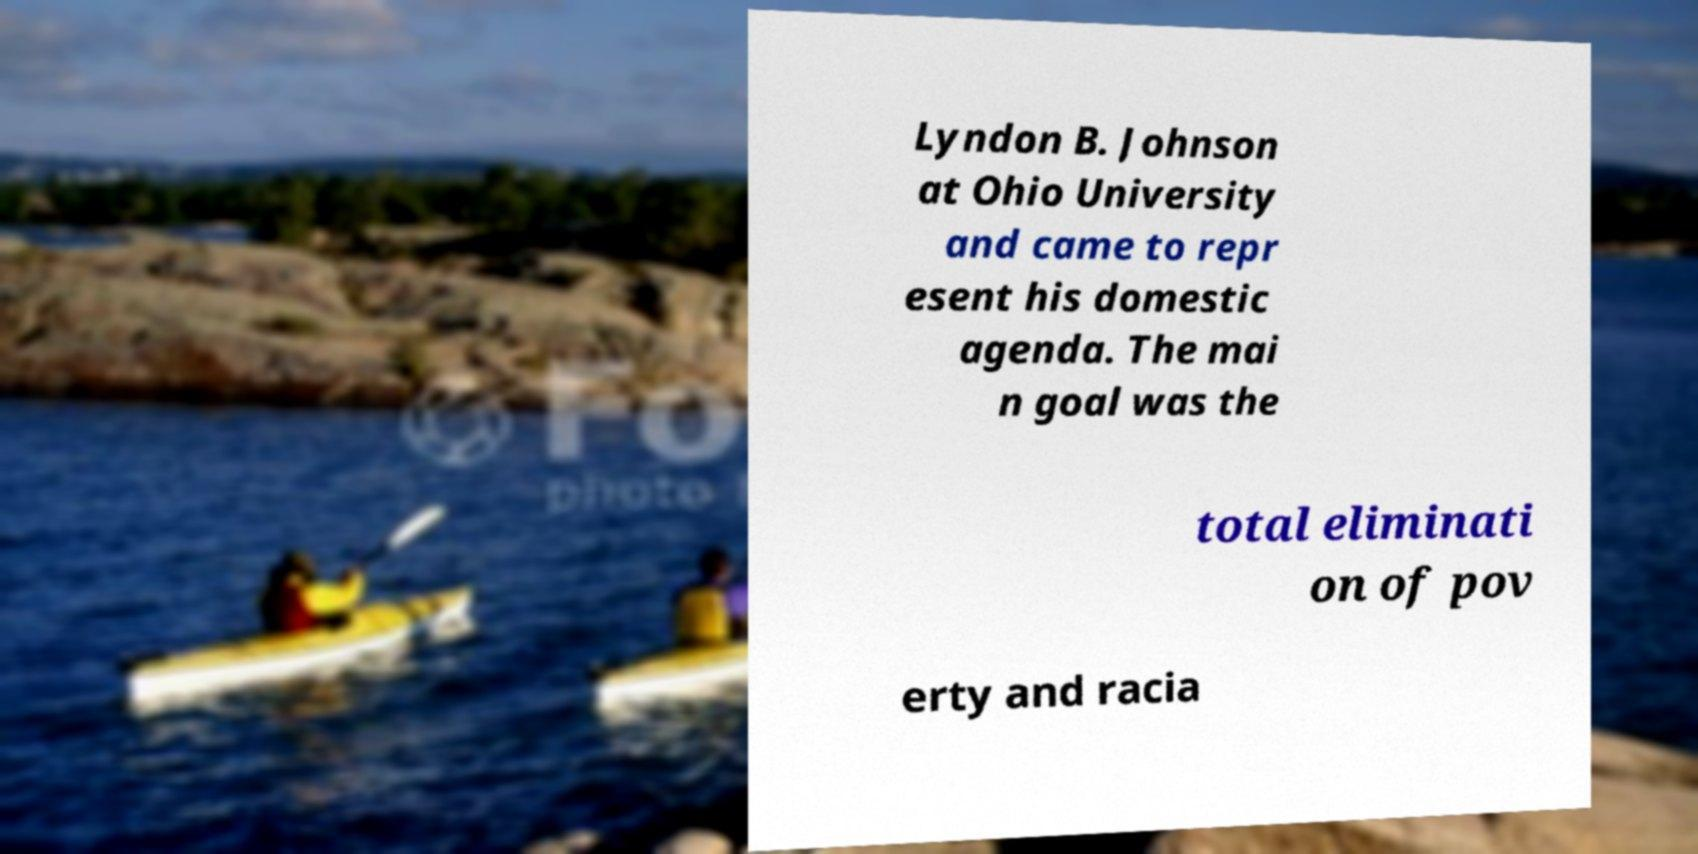Could you assist in decoding the text presented in this image and type it out clearly? Lyndon B. Johnson at Ohio University and came to repr esent his domestic agenda. The mai n goal was the total eliminati on of pov erty and racia 